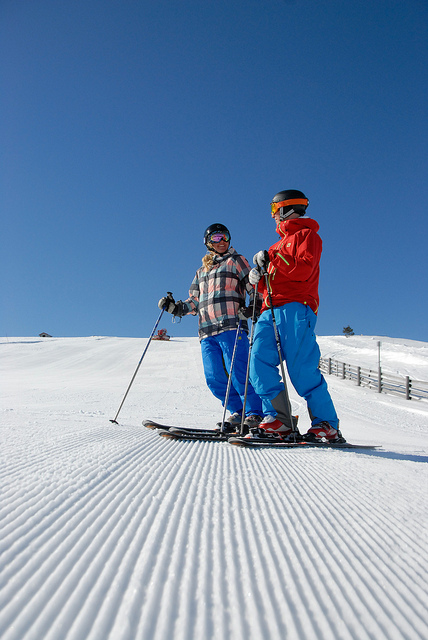How many chairs are in the picture? 0 